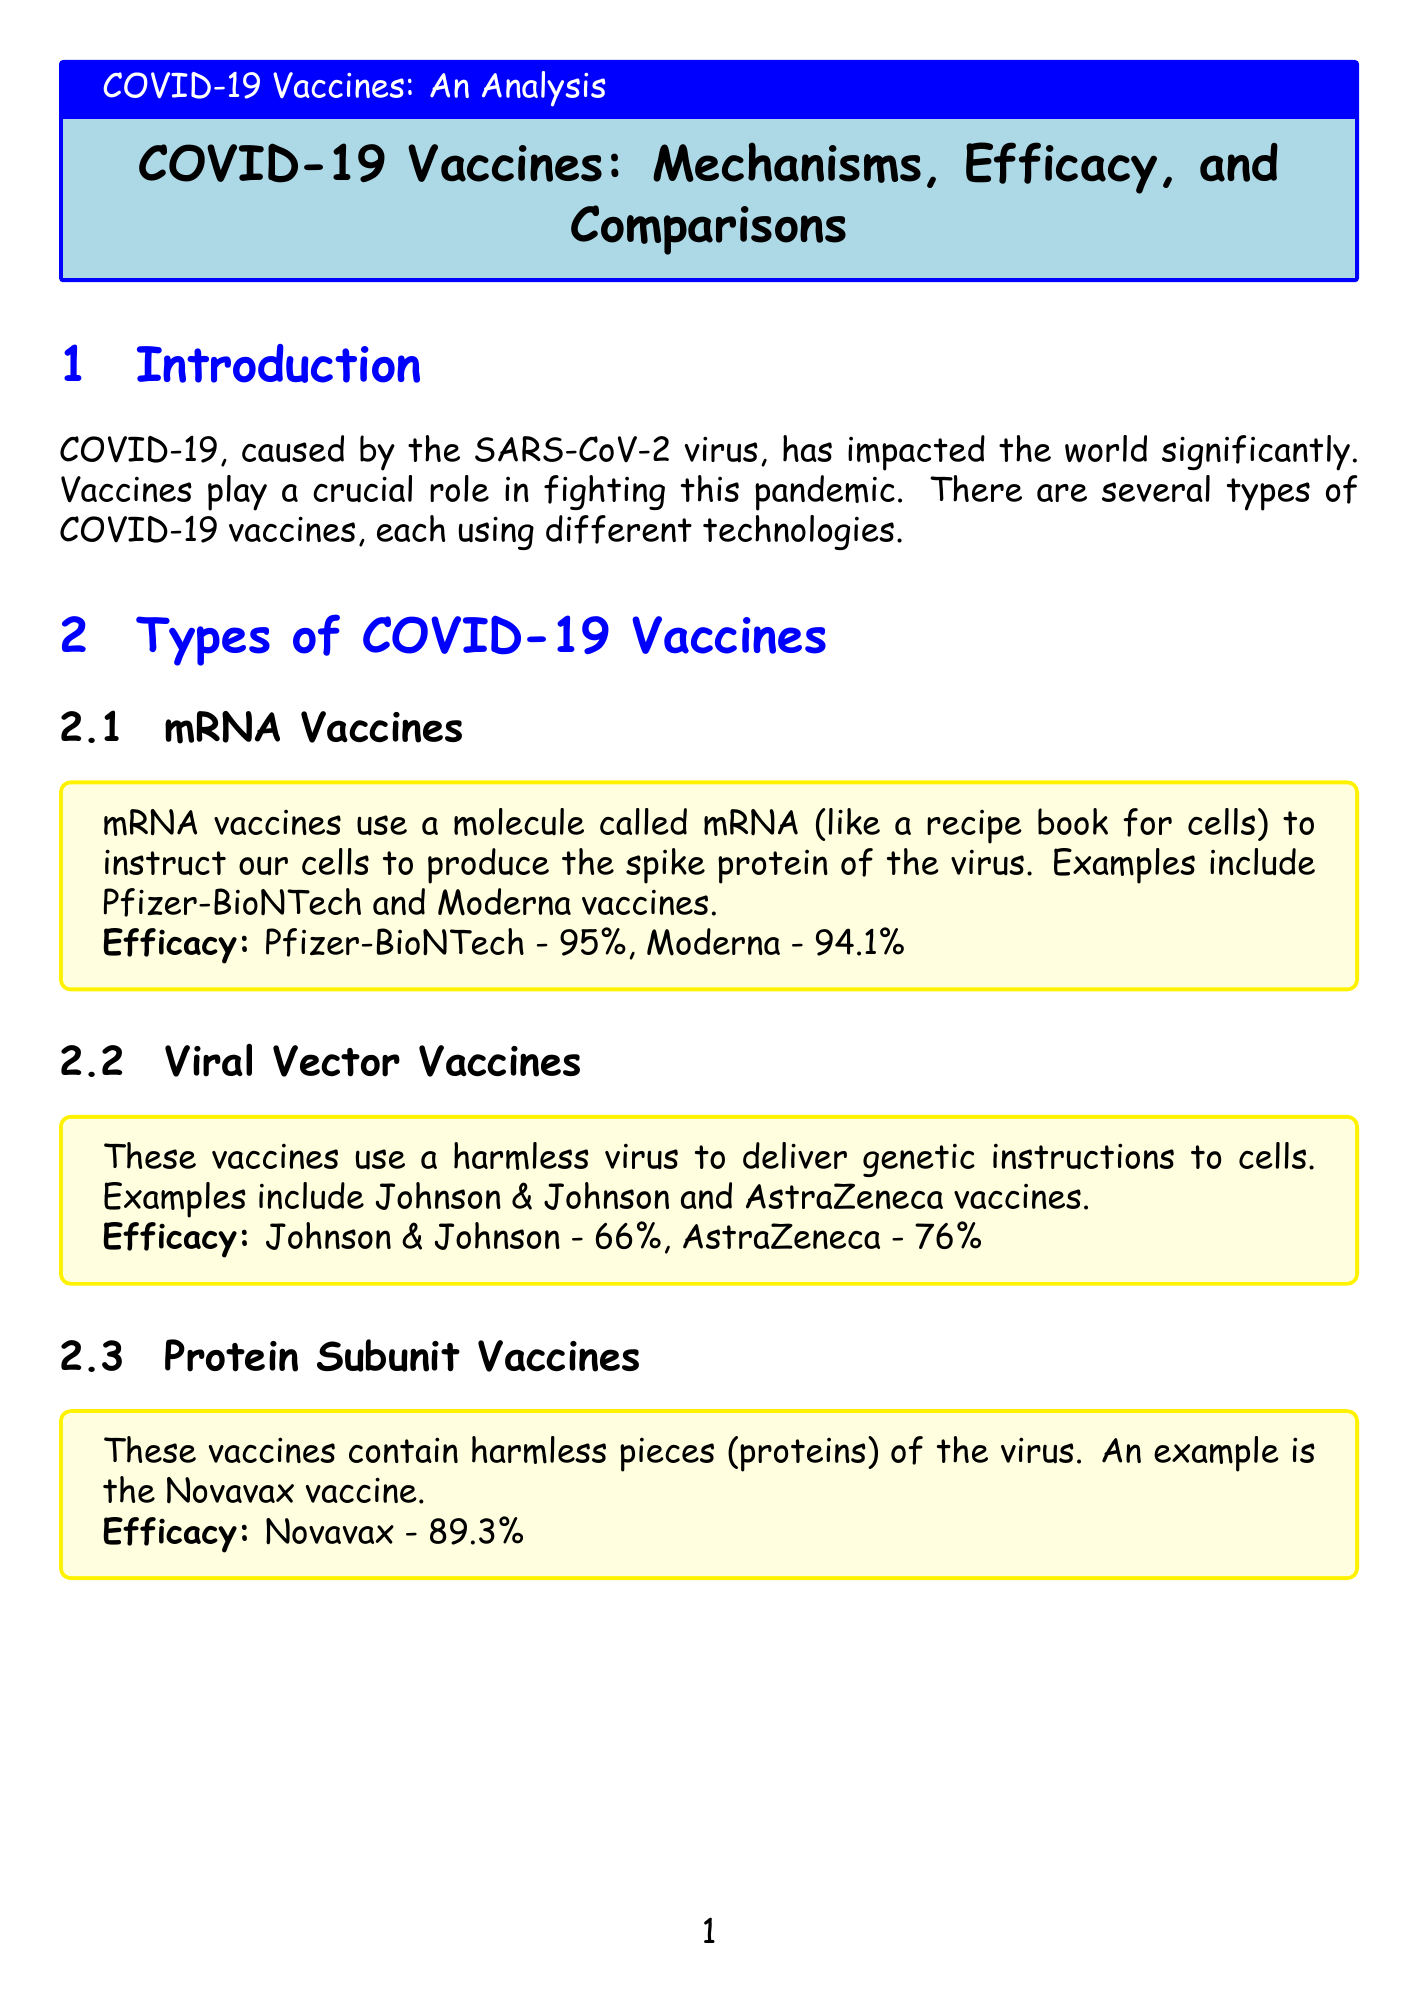What is the efficacy of the Pfizer-BioNTech vaccine? The report states that the efficacy of the Pfizer-BioNTech vaccine is 95%.
Answer: 95% What type of vaccine is Johnson & Johnson? The document lists Johnson & Johnson as a viral vector vaccine.
Answer: Viral vector Which vaccine type has the lowest efficacy rate? The efficacy rates provided indicate that Sinovac has the lowest efficacy at 50.4%.
Answer: Sinovac How many types of vaccines are mentioned in the report? The report introduces four types of vaccines used against COVID-19.
Answer: Four What is the storage requirement for some vaccines? According to the facts, some vaccines require ultra-cold storage, as low as -70°C (-94°F).
Answer: Ultra-cold storage What is the main ingredient used in mRNA vaccines? The explanation describes mRNA as the main ingredient used to instruct cells to produce the spike protein.
Answer: mRNA What percentage of the global distribution is represented by protein subunit vaccines? The global distribution data indicates that protein subunit vaccines make up 17%.
Answer: 17% Which vaccine has an efficacy rate of 66%? The report specifies that the Johnson & Johnson vaccine has an efficacy rate of 66%.
Answer: Johnson & Johnson How long did it take to develop COVID-19 vaccines? The report notes that the development of COVID-19 vaccines was the fastest in history, taking less than a year.
Answer: Less than a year 